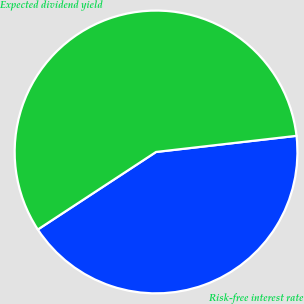Convert chart. <chart><loc_0><loc_0><loc_500><loc_500><pie_chart><fcel>Risk-free interest rate<fcel>Expected dividend yield<nl><fcel>42.58%<fcel>57.42%<nl></chart> 